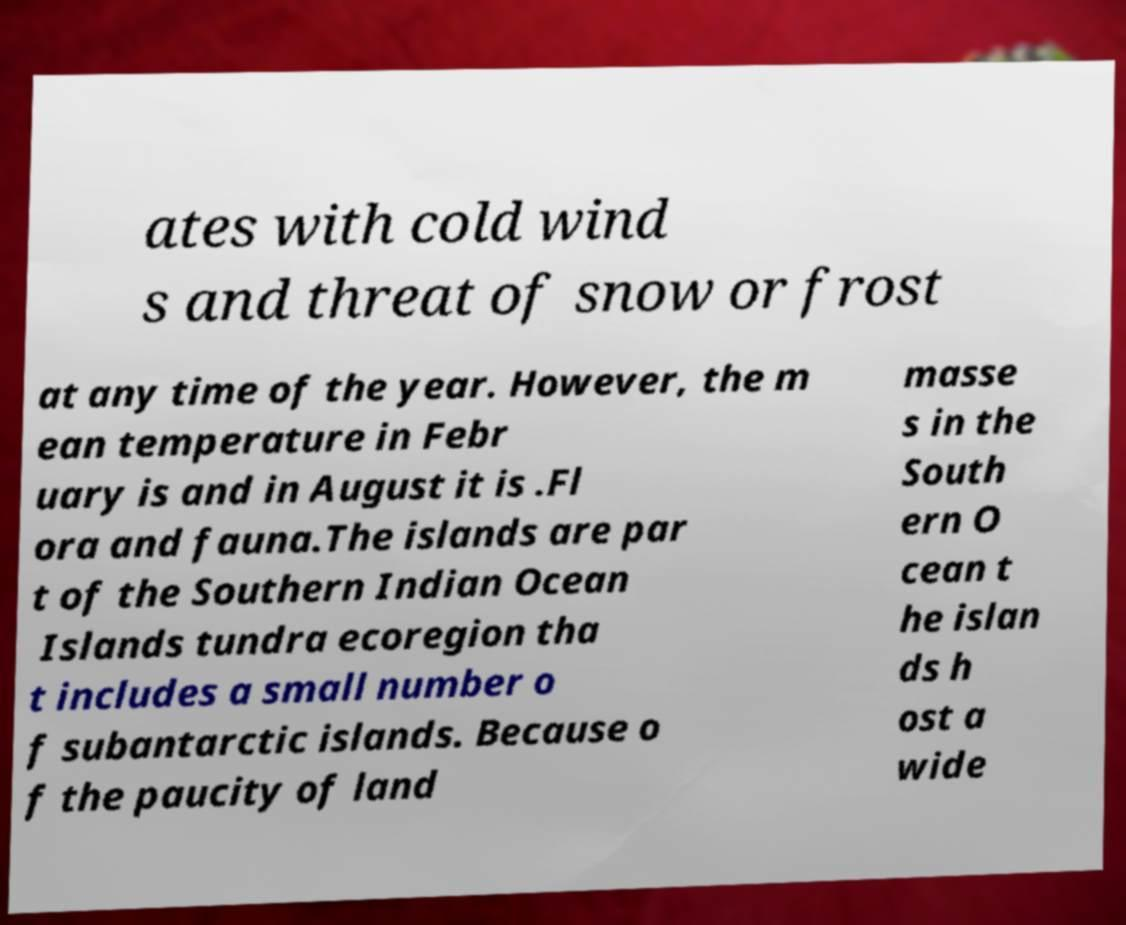I need the written content from this picture converted into text. Can you do that? ates with cold wind s and threat of snow or frost at any time of the year. However, the m ean temperature in Febr uary is and in August it is .Fl ora and fauna.The islands are par t of the Southern Indian Ocean Islands tundra ecoregion tha t includes a small number o f subantarctic islands. Because o f the paucity of land masse s in the South ern O cean t he islan ds h ost a wide 